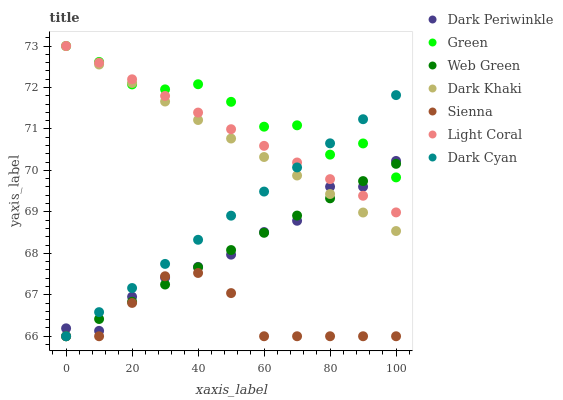Does Sienna have the minimum area under the curve?
Answer yes or no. Yes. Does Green have the maximum area under the curve?
Answer yes or no. Yes. Does Light Coral have the minimum area under the curve?
Answer yes or no. No. Does Light Coral have the maximum area under the curve?
Answer yes or no. No. Is Dark Khaki the smoothest?
Answer yes or no. Yes. Is Green the roughest?
Answer yes or no. Yes. Is Light Coral the smoothest?
Answer yes or no. No. Is Light Coral the roughest?
Answer yes or no. No. Does Sienna have the lowest value?
Answer yes or no. Yes. Does Light Coral have the lowest value?
Answer yes or no. No. Does Green have the highest value?
Answer yes or no. Yes. Does Web Green have the highest value?
Answer yes or no. No. Is Sienna less than Light Coral?
Answer yes or no. Yes. Is Dark Khaki greater than Sienna?
Answer yes or no. Yes. Does Light Coral intersect Web Green?
Answer yes or no. Yes. Is Light Coral less than Web Green?
Answer yes or no. No. Is Light Coral greater than Web Green?
Answer yes or no. No. Does Sienna intersect Light Coral?
Answer yes or no. No. 